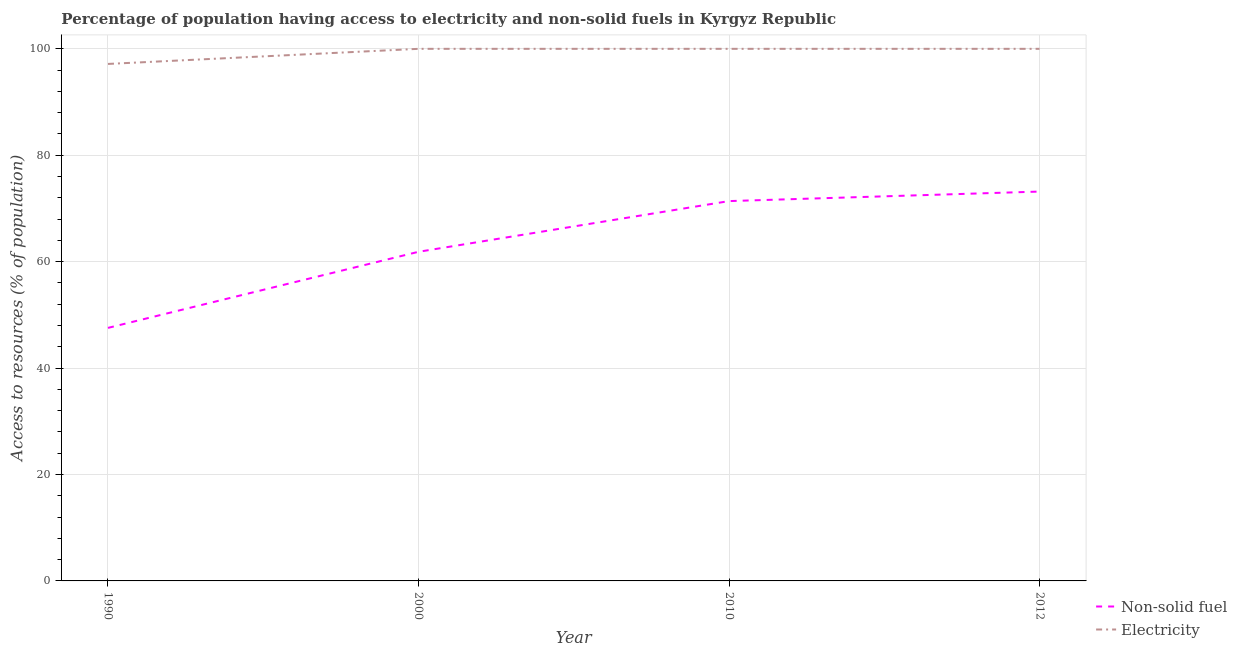How many different coloured lines are there?
Offer a terse response. 2. Does the line corresponding to percentage of population having access to non-solid fuel intersect with the line corresponding to percentage of population having access to electricity?
Your answer should be compact. No. Is the number of lines equal to the number of legend labels?
Offer a very short reply. Yes. What is the percentage of population having access to non-solid fuel in 2010?
Ensure brevity in your answer.  71.38. Across all years, what is the minimum percentage of population having access to electricity?
Your answer should be compact. 97.16. In which year was the percentage of population having access to electricity minimum?
Give a very brief answer. 1990. What is the total percentage of population having access to non-solid fuel in the graph?
Make the answer very short. 253.97. What is the difference between the percentage of population having access to non-solid fuel in 2000 and that in 2012?
Your answer should be very brief. -11.32. What is the difference between the percentage of population having access to electricity in 1990 and the percentage of population having access to non-solid fuel in 2000?
Give a very brief answer. 35.31. What is the average percentage of population having access to electricity per year?
Your answer should be very brief. 99.29. In the year 2012, what is the difference between the percentage of population having access to non-solid fuel and percentage of population having access to electricity?
Provide a short and direct response. -26.82. What is the ratio of the percentage of population having access to non-solid fuel in 1990 to that in 2012?
Ensure brevity in your answer.  0.65. Is the percentage of population having access to electricity in 2010 less than that in 2012?
Provide a succinct answer. No. What is the difference between the highest and the lowest percentage of population having access to electricity?
Provide a succinct answer. 2.84. Is the sum of the percentage of population having access to electricity in 2000 and 2010 greater than the maximum percentage of population having access to non-solid fuel across all years?
Offer a very short reply. Yes. Does the percentage of population having access to non-solid fuel monotonically increase over the years?
Your response must be concise. Yes. Is the percentage of population having access to electricity strictly less than the percentage of population having access to non-solid fuel over the years?
Keep it short and to the point. No. How many lines are there?
Provide a succinct answer. 2. What is the difference between two consecutive major ticks on the Y-axis?
Keep it short and to the point. 20. Does the graph contain any zero values?
Your response must be concise. No. Does the graph contain grids?
Offer a very short reply. Yes. Where does the legend appear in the graph?
Offer a very short reply. Bottom right. What is the title of the graph?
Provide a succinct answer. Percentage of population having access to electricity and non-solid fuels in Kyrgyz Republic. Does "Lower secondary education" appear as one of the legend labels in the graph?
Provide a succinct answer. No. What is the label or title of the X-axis?
Your answer should be compact. Year. What is the label or title of the Y-axis?
Make the answer very short. Access to resources (% of population). What is the Access to resources (% of population) in Non-solid fuel in 1990?
Your response must be concise. 47.55. What is the Access to resources (% of population) in Electricity in 1990?
Provide a short and direct response. 97.16. What is the Access to resources (% of population) of Non-solid fuel in 2000?
Offer a terse response. 61.85. What is the Access to resources (% of population) in Non-solid fuel in 2010?
Your response must be concise. 71.38. What is the Access to resources (% of population) of Electricity in 2010?
Give a very brief answer. 100. What is the Access to resources (% of population) of Non-solid fuel in 2012?
Ensure brevity in your answer.  73.18. Across all years, what is the maximum Access to resources (% of population) in Non-solid fuel?
Give a very brief answer. 73.18. Across all years, what is the minimum Access to resources (% of population) in Non-solid fuel?
Ensure brevity in your answer.  47.55. Across all years, what is the minimum Access to resources (% of population) in Electricity?
Keep it short and to the point. 97.16. What is the total Access to resources (% of population) of Non-solid fuel in the graph?
Give a very brief answer. 253.97. What is the total Access to resources (% of population) in Electricity in the graph?
Provide a short and direct response. 397.16. What is the difference between the Access to resources (% of population) of Non-solid fuel in 1990 and that in 2000?
Ensure brevity in your answer.  -14.3. What is the difference between the Access to resources (% of population) of Electricity in 1990 and that in 2000?
Your answer should be very brief. -2.84. What is the difference between the Access to resources (% of population) of Non-solid fuel in 1990 and that in 2010?
Give a very brief answer. -23.83. What is the difference between the Access to resources (% of population) of Electricity in 1990 and that in 2010?
Make the answer very short. -2.84. What is the difference between the Access to resources (% of population) in Non-solid fuel in 1990 and that in 2012?
Your response must be concise. -25.62. What is the difference between the Access to resources (% of population) in Electricity in 1990 and that in 2012?
Provide a short and direct response. -2.84. What is the difference between the Access to resources (% of population) in Non-solid fuel in 2000 and that in 2010?
Ensure brevity in your answer.  -9.53. What is the difference between the Access to resources (% of population) in Non-solid fuel in 2000 and that in 2012?
Offer a terse response. -11.32. What is the difference between the Access to resources (% of population) of Electricity in 2000 and that in 2012?
Offer a very short reply. 0. What is the difference between the Access to resources (% of population) of Non-solid fuel in 2010 and that in 2012?
Offer a terse response. -1.79. What is the difference between the Access to resources (% of population) in Electricity in 2010 and that in 2012?
Your answer should be very brief. 0. What is the difference between the Access to resources (% of population) in Non-solid fuel in 1990 and the Access to resources (% of population) in Electricity in 2000?
Your answer should be very brief. -52.45. What is the difference between the Access to resources (% of population) of Non-solid fuel in 1990 and the Access to resources (% of population) of Electricity in 2010?
Offer a very short reply. -52.45. What is the difference between the Access to resources (% of population) in Non-solid fuel in 1990 and the Access to resources (% of population) in Electricity in 2012?
Make the answer very short. -52.45. What is the difference between the Access to resources (% of population) in Non-solid fuel in 2000 and the Access to resources (% of population) in Electricity in 2010?
Provide a succinct answer. -38.15. What is the difference between the Access to resources (% of population) of Non-solid fuel in 2000 and the Access to resources (% of population) of Electricity in 2012?
Make the answer very short. -38.15. What is the difference between the Access to resources (% of population) of Non-solid fuel in 2010 and the Access to resources (% of population) of Electricity in 2012?
Offer a terse response. -28.62. What is the average Access to resources (% of population) of Non-solid fuel per year?
Offer a terse response. 63.49. What is the average Access to resources (% of population) of Electricity per year?
Provide a short and direct response. 99.29. In the year 1990, what is the difference between the Access to resources (% of population) in Non-solid fuel and Access to resources (% of population) in Electricity?
Offer a terse response. -49.61. In the year 2000, what is the difference between the Access to resources (% of population) of Non-solid fuel and Access to resources (% of population) of Electricity?
Make the answer very short. -38.15. In the year 2010, what is the difference between the Access to resources (% of population) in Non-solid fuel and Access to resources (% of population) in Electricity?
Offer a very short reply. -28.62. In the year 2012, what is the difference between the Access to resources (% of population) of Non-solid fuel and Access to resources (% of population) of Electricity?
Provide a short and direct response. -26.82. What is the ratio of the Access to resources (% of population) of Non-solid fuel in 1990 to that in 2000?
Your response must be concise. 0.77. What is the ratio of the Access to resources (% of population) in Electricity in 1990 to that in 2000?
Make the answer very short. 0.97. What is the ratio of the Access to resources (% of population) of Non-solid fuel in 1990 to that in 2010?
Make the answer very short. 0.67. What is the ratio of the Access to resources (% of population) in Electricity in 1990 to that in 2010?
Make the answer very short. 0.97. What is the ratio of the Access to resources (% of population) of Non-solid fuel in 1990 to that in 2012?
Provide a short and direct response. 0.65. What is the ratio of the Access to resources (% of population) in Electricity in 1990 to that in 2012?
Make the answer very short. 0.97. What is the ratio of the Access to resources (% of population) of Non-solid fuel in 2000 to that in 2010?
Provide a short and direct response. 0.87. What is the ratio of the Access to resources (% of population) in Non-solid fuel in 2000 to that in 2012?
Make the answer very short. 0.85. What is the ratio of the Access to resources (% of population) in Non-solid fuel in 2010 to that in 2012?
Keep it short and to the point. 0.98. What is the difference between the highest and the second highest Access to resources (% of population) in Non-solid fuel?
Offer a very short reply. 1.79. What is the difference between the highest and the lowest Access to resources (% of population) in Non-solid fuel?
Make the answer very short. 25.62. What is the difference between the highest and the lowest Access to resources (% of population) of Electricity?
Give a very brief answer. 2.84. 